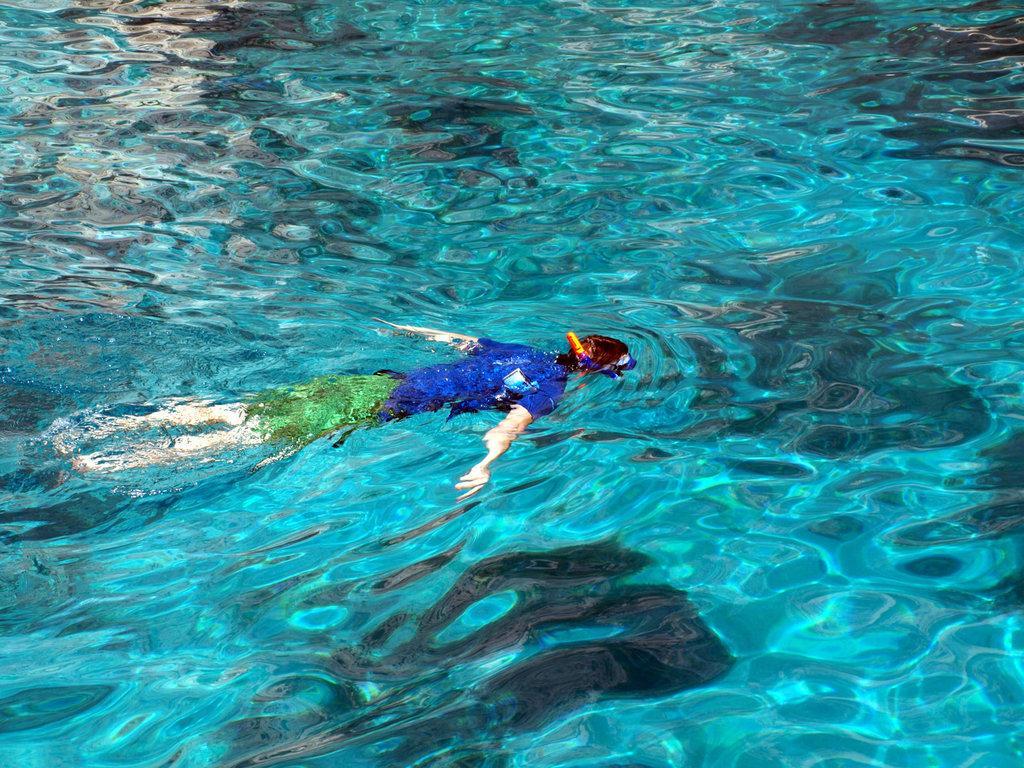Can you describe this image briefly? This picture looks like a human swimming in the water. 